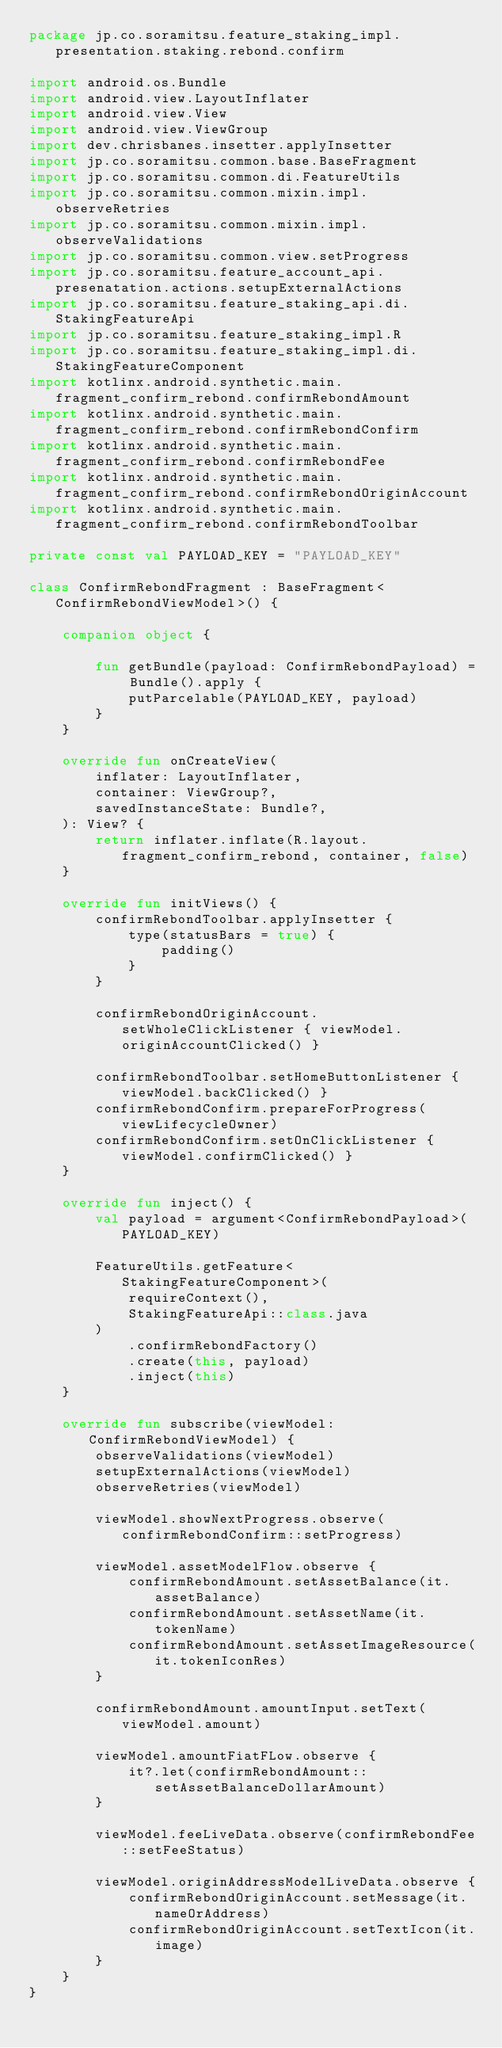<code> <loc_0><loc_0><loc_500><loc_500><_Kotlin_>package jp.co.soramitsu.feature_staking_impl.presentation.staking.rebond.confirm

import android.os.Bundle
import android.view.LayoutInflater
import android.view.View
import android.view.ViewGroup
import dev.chrisbanes.insetter.applyInsetter
import jp.co.soramitsu.common.base.BaseFragment
import jp.co.soramitsu.common.di.FeatureUtils
import jp.co.soramitsu.common.mixin.impl.observeRetries
import jp.co.soramitsu.common.mixin.impl.observeValidations
import jp.co.soramitsu.common.view.setProgress
import jp.co.soramitsu.feature_account_api.presenatation.actions.setupExternalActions
import jp.co.soramitsu.feature_staking_api.di.StakingFeatureApi
import jp.co.soramitsu.feature_staking_impl.R
import jp.co.soramitsu.feature_staking_impl.di.StakingFeatureComponent
import kotlinx.android.synthetic.main.fragment_confirm_rebond.confirmRebondAmount
import kotlinx.android.synthetic.main.fragment_confirm_rebond.confirmRebondConfirm
import kotlinx.android.synthetic.main.fragment_confirm_rebond.confirmRebondFee
import kotlinx.android.synthetic.main.fragment_confirm_rebond.confirmRebondOriginAccount
import kotlinx.android.synthetic.main.fragment_confirm_rebond.confirmRebondToolbar

private const val PAYLOAD_KEY = "PAYLOAD_KEY"

class ConfirmRebondFragment : BaseFragment<ConfirmRebondViewModel>() {

    companion object {

        fun getBundle(payload: ConfirmRebondPayload) = Bundle().apply {
            putParcelable(PAYLOAD_KEY, payload)
        }
    }

    override fun onCreateView(
        inflater: LayoutInflater,
        container: ViewGroup?,
        savedInstanceState: Bundle?,
    ): View? {
        return inflater.inflate(R.layout.fragment_confirm_rebond, container, false)
    }

    override fun initViews() {
        confirmRebondToolbar.applyInsetter {
            type(statusBars = true) {
                padding()
            }
        }

        confirmRebondOriginAccount.setWholeClickListener { viewModel.originAccountClicked() }

        confirmRebondToolbar.setHomeButtonListener { viewModel.backClicked() }
        confirmRebondConfirm.prepareForProgress(viewLifecycleOwner)
        confirmRebondConfirm.setOnClickListener { viewModel.confirmClicked() }
    }

    override fun inject() {
        val payload = argument<ConfirmRebondPayload>(PAYLOAD_KEY)

        FeatureUtils.getFeature<StakingFeatureComponent>(
            requireContext(),
            StakingFeatureApi::class.java
        )
            .confirmRebondFactory()
            .create(this, payload)
            .inject(this)
    }

    override fun subscribe(viewModel: ConfirmRebondViewModel) {
        observeValidations(viewModel)
        setupExternalActions(viewModel)
        observeRetries(viewModel)

        viewModel.showNextProgress.observe(confirmRebondConfirm::setProgress)

        viewModel.assetModelFlow.observe {
            confirmRebondAmount.setAssetBalance(it.assetBalance)
            confirmRebondAmount.setAssetName(it.tokenName)
            confirmRebondAmount.setAssetImageResource(it.tokenIconRes)
        }

        confirmRebondAmount.amountInput.setText(viewModel.amount)

        viewModel.amountFiatFLow.observe {
            it?.let(confirmRebondAmount::setAssetBalanceDollarAmount)
        }

        viewModel.feeLiveData.observe(confirmRebondFee::setFeeStatus)

        viewModel.originAddressModelLiveData.observe {
            confirmRebondOriginAccount.setMessage(it.nameOrAddress)
            confirmRebondOriginAccount.setTextIcon(it.image)
        }
    }
}
</code> 